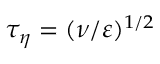Convert formula to latex. <formula><loc_0><loc_0><loc_500><loc_500>\tau _ { \eta } = ( \nu / \varepsilon ) ^ { 1 / 2 }</formula> 